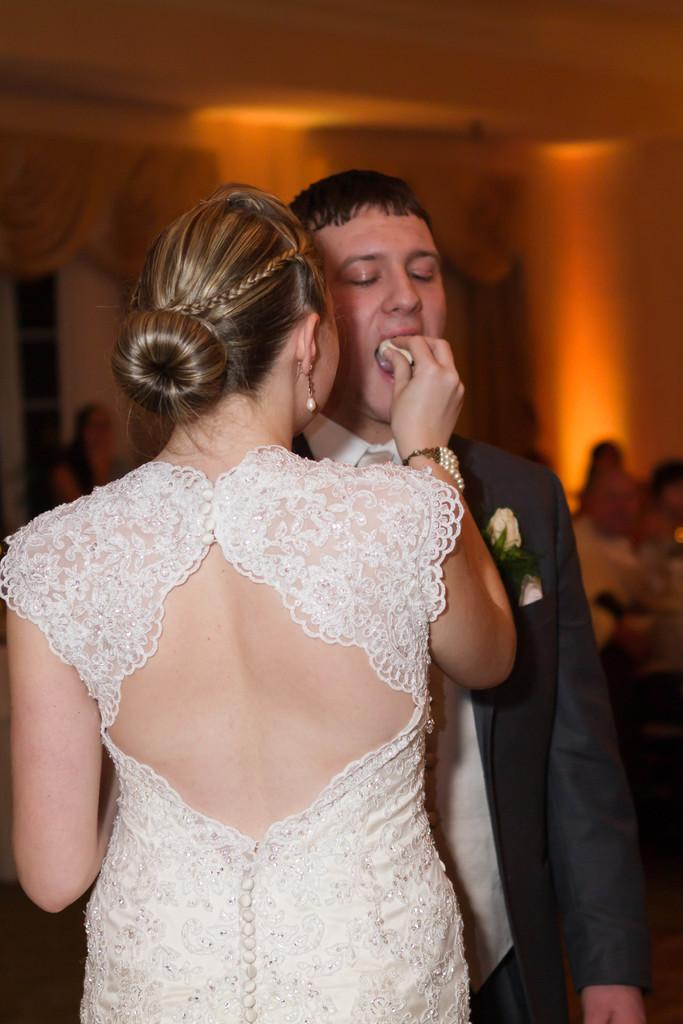What is the woman in the image doing? The woman is holding food and feeding it to a man. What is the woman holding in the image? The woman is holding food in the image. What can be seen in the background of the image? There are people, a wall, and curtains in the background of the image. Can you see a bubble floating in the air in the image? No, there is no bubble visible in the image. 